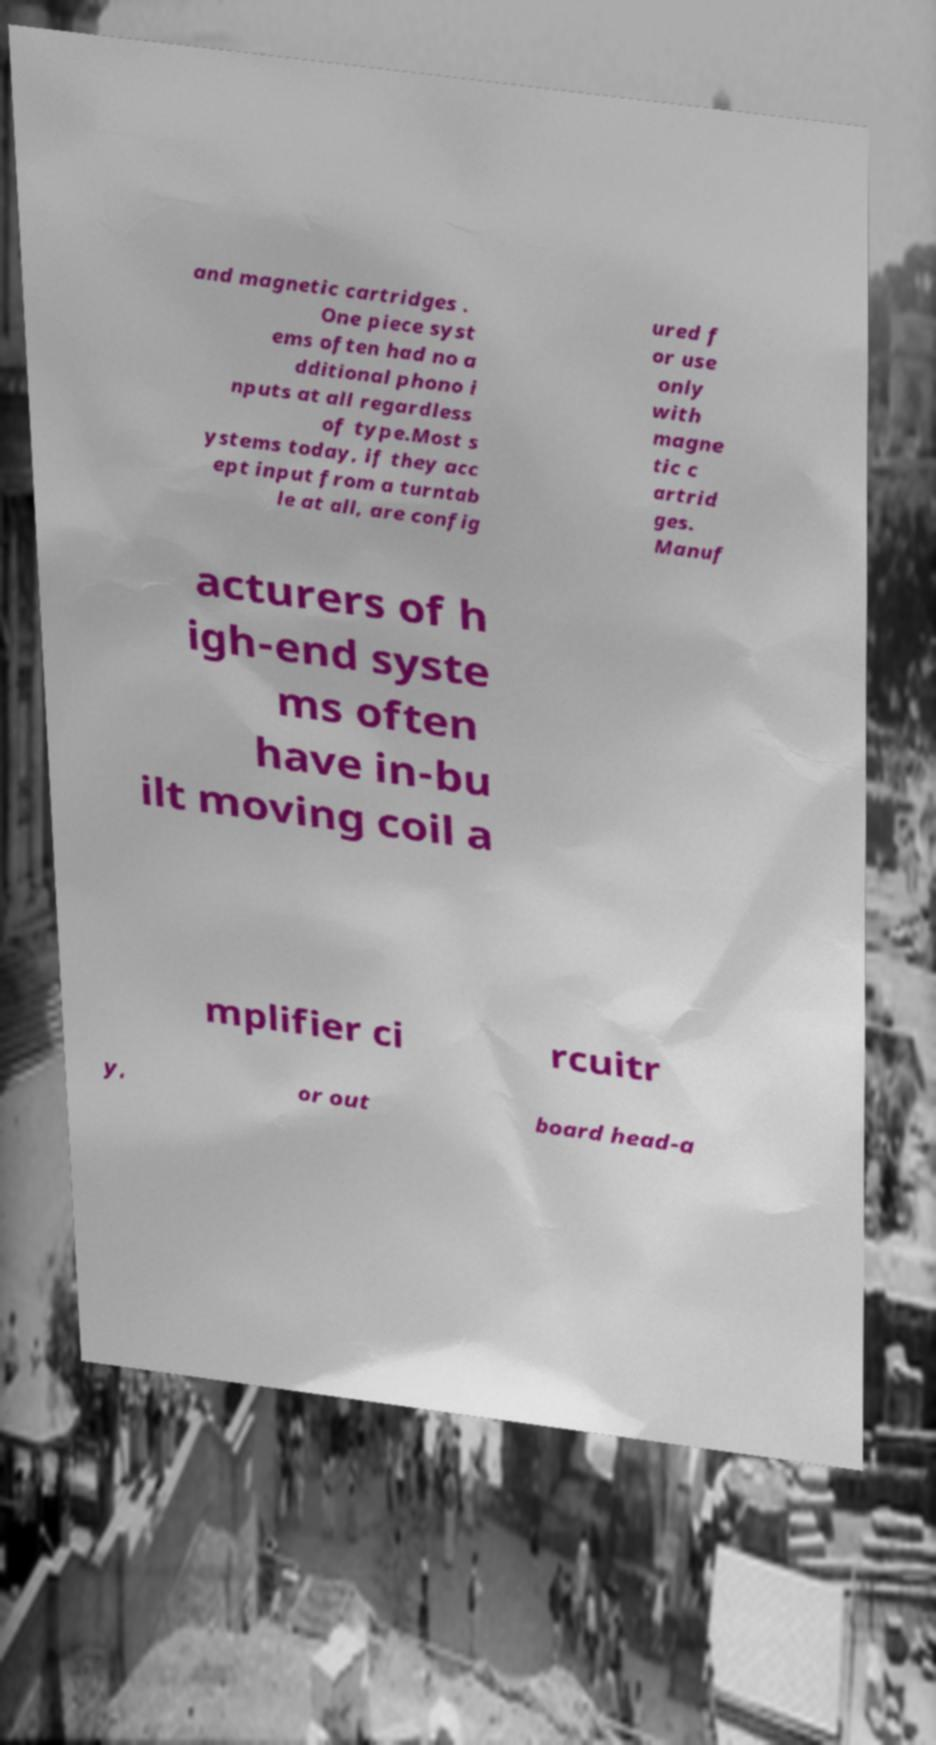Can you accurately transcribe the text from the provided image for me? and magnetic cartridges . One piece syst ems often had no a dditional phono i nputs at all regardless of type.Most s ystems today, if they acc ept input from a turntab le at all, are config ured f or use only with magne tic c artrid ges. Manuf acturers of h igh-end syste ms often have in-bu ilt moving coil a mplifier ci rcuitr y, or out board head-a 